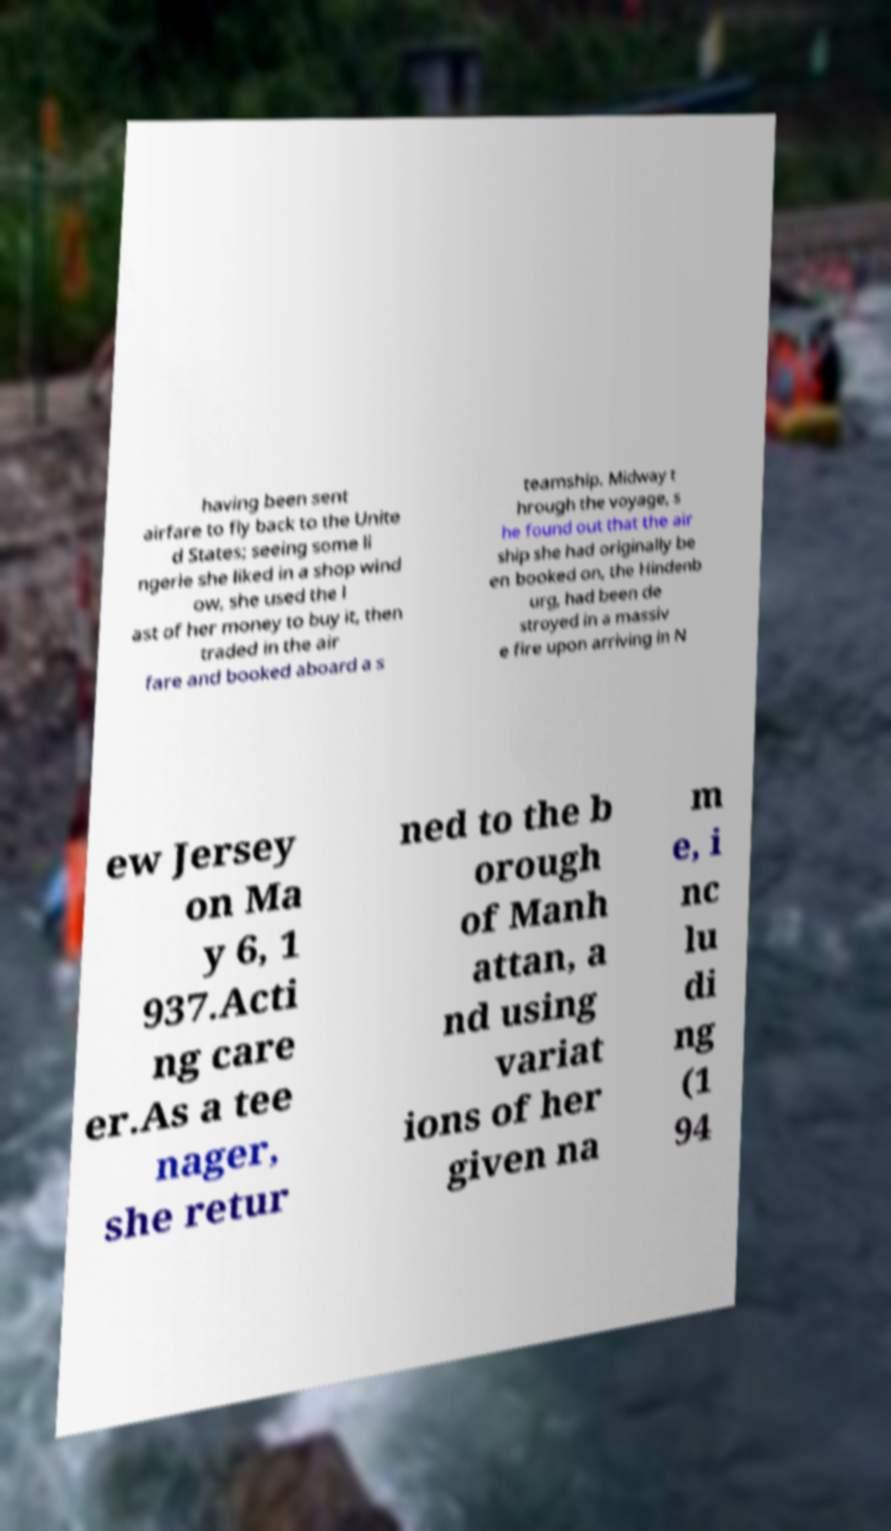Can you read and provide the text displayed in the image?This photo seems to have some interesting text. Can you extract and type it out for me? having been sent airfare to fly back to the Unite d States; seeing some li ngerie she liked in a shop wind ow, she used the l ast of her money to buy it, then traded in the air fare and booked aboard a s teamship. Midway t hrough the voyage, s he found out that the air ship she had originally be en booked on, the Hindenb urg, had been de stroyed in a massiv e fire upon arriving in N ew Jersey on Ma y 6, 1 937.Acti ng care er.As a tee nager, she retur ned to the b orough of Manh attan, a nd using variat ions of her given na m e, i nc lu di ng (1 94 